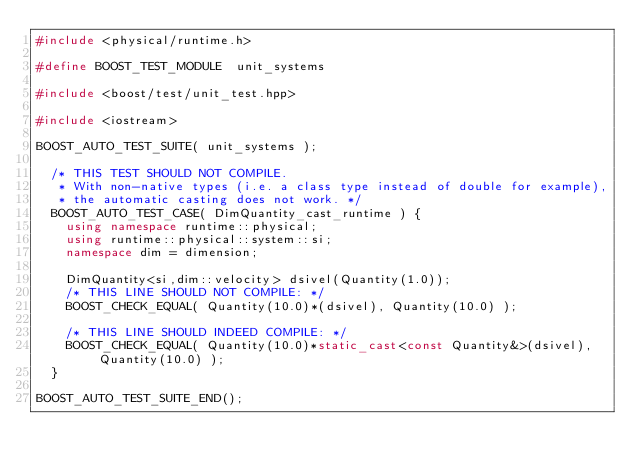Convert code to text. <code><loc_0><loc_0><loc_500><loc_500><_C++_>#include <physical/runtime.h>

#define BOOST_TEST_MODULE  unit_systems

#include <boost/test/unit_test.hpp>

#include <iostream>

BOOST_AUTO_TEST_SUITE( unit_systems );

  /* THIS TEST SHOULD NOT COMPILE.
   * With non-native types (i.e. a class type instead of double for example),
   * the automatic casting does not work. */
  BOOST_AUTO_TEST_CASE( DimQuantity_cast_runtime ) {
    using namespace runtime::physical;
    using runtime::physical::system::si;
    namespace dim = dimension;

    DimQuantity<si,dim::velocity> dsivel(Quantity(1.0));
    /* THIS LINE SHOULD NOT COMPILE: */
    BOOST_CHECK_EQUAL( Quantity(10.0)*(dsivel), Quantity(10.0) );

    /* THIS LINE SHOULD INDEED COMPILE: */
    BOOST_CHECK_EQUAL( Quantity(10.0)*static_cast<const Quantity&>(dsivel), Quantity(10.0) );
  }

BOOST_AUTO_TEST_SUITE_END();

</code> 